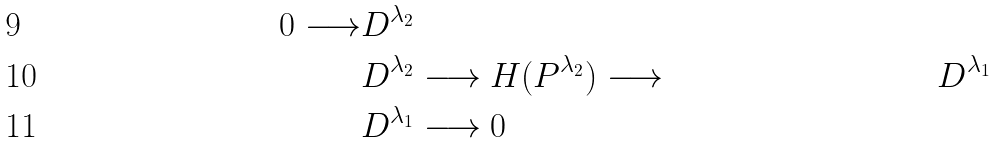Convert formula to latex. <formula><loc_0><loc_0><loc_500><loc_500>0 \longrightarrow & D ^ { \lambda _ { 2 } } \\ & D ^ { \lambda _ { 2 } } \longrightarrow H ( P ^ { \lambda _ { 2 } } ) \longrightarrow & D ^ { \lambda _ { 1 } } \\ & D ^ { \lambda _ { 1 } } \longrightarrow 0</formula> 